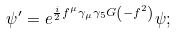<formula> <loc_0><loc_0><loc_500><loc_500>\psi ^ { \prime } = e ^ { \frac { i } { 2 } f ^ { \mu } \gamma _ { \mu } \gamma _ { 5 } G \left ( - f ^ { 2 } \right ) } \psi ;</formula> 